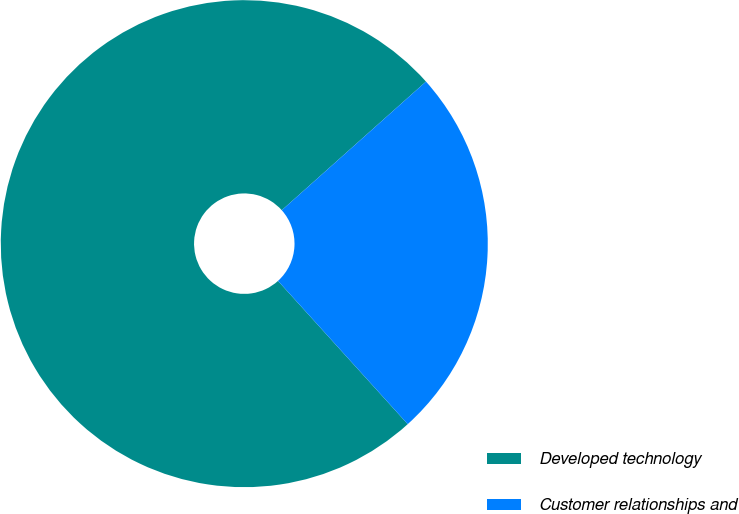Convert chart. <chart><loc_0><loc_0><loc_500><loc_500><pie_chart><fcel>Developed technology<fcel>Customer relationships and<nl><fcel>75.12%<fcel>24.88%<nl></chart> 